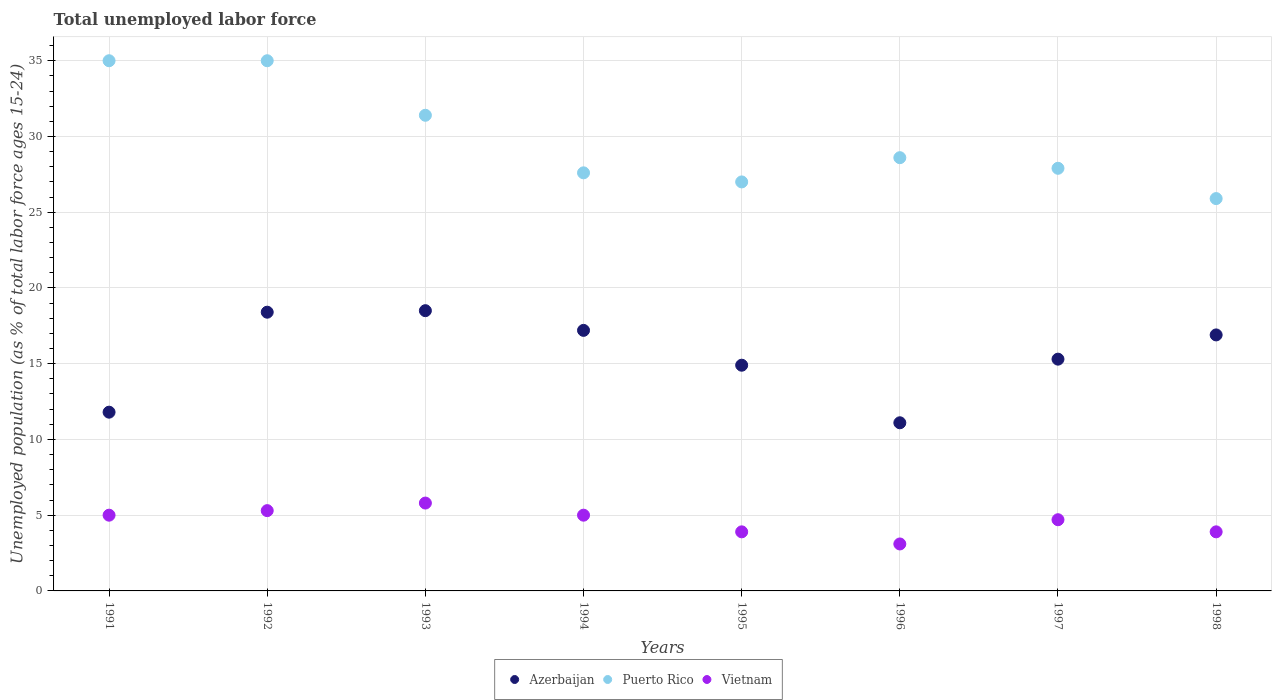How many different coloured dotlines are there?
Offer a very short reply. 3. Is the number of dotlines equal to the number of legend labels?
Provide a succinct answer. Yes. What is the percentage of unemployed population in in Puerto Rico in 1998?
Your response must be concise. 25.9. Across all years, what is the minimum percentage of unemployed population in in Vietnam?
Make the answer very short. 3.1. In which year was the percentage of unemployed population in in Vietnam maximum?
Provide a short and direct response. 1993. What is the total percentage of unemployed population in in Vietnam in the graph?
Give a very brief answer. 36.7. What is the difference between the percentage of unemployed population in in Vietnam in 1995 and that in 1997?
Make the answer very short. -0.8. What is the difference between the percentage of unemployed population in in Vietnam in 1993 and the percentage of unemployed population in in Azerbaijan in 1995?
Give a very brief answer. -9.1. What is the average percentage of unemployed population in in Azerbaijan per year?
Your answer should be very brief. 15.51. In the year 1992, what is the difference between the percentage of unemployed population in in Azerbaijan and percentage of unemployed population in in Puerto Rico?
Make the answer very short. -16.6. In how many years, is the percentage of unemployed population in in Vietnam greater than 6 %?
Ensure brevity in your answer.  0. What is the ratio of the percentage of unemployed population in in Vietnam in 1991 to that in 1997?
Offer a terse response. 1.06. Is the percentage of unemployed population in in Azerbaijan in 1994 less than that in 1997?
Offer a terse response. No. What is the difference between the highest and the second highest percentage of unemployed population in in Azerbaijan?
Your answer should be compact. 0.1. What is the difference between the highest and the lowest percentage of unemployed population in in Vietnam?
Make the answer very short. 2.7. In how many years, is the percentage of unemployed population in in Vietnam greater than the average percentage of unemployed population in in Vietnam taken over all years?
Your answer should be very brief. 5. Does the percentage of unemployed population in in Vietnam monotonically increase over the years?
Provide a succinct answer. No. Is the percentage of unemployed population in in Vietnam strictly greater than the percentage of unemployed population in in Puerto Rico over the years?
Your response must be concise. No. Is the percentage of unemployed population in in Puerto Rico strictly less than the percentage of unemployed population in in Vietnam over the years?
Your answer should be very brief. No. How many years are there in the graph?
Offer a terse response. 8. What is the difference between two consecutive major ticks on the Y-axis?
Your response must be concise. 5. Are the values on the major ticks of Y-axis written in scientific E-notation?
Offer a very short reply. No. Does the graph contain any zero values?
Provide a short and direct response. No. Where does the legend appear in the graph?
Your response must be concise. Bottom center. How many legend labels are there?
Offer a very short reply. 3. What is the title of the graph?
Keep it short and to the point. Total unemployed labor force. Does "Mexico" appear as one of the legend labels in the graph?
Your response must be concise. No. What is the label or title of the X-axis?
Your response must be concise. Years. What is the label or title of the Y-axis?
Your answer should be compact. Unemployed population (as % of total labor force ages 15-24). What is the Unemployed population (as % of total labor force ages 15-24) in Azerbaijan in 1991?
Offer a terse response. 11.8. What is the Unemployed population (as % of total labor force ages 15-24) in Puerto Rico in 1991?
Offer a very short reply. 35. What is the Unemployed population (as % of total labor force ages 15-24) of Vietnam in 1991?
Your answer should be very brief. 5. What is the Unemployed population (as % of total labor force ages 15-24) in Azerbaijan in 1992?
Offer a very short reply. 18.4. What is the Unemployed population (as % of total labor force ages 15-24) of Puerto Rico in 1992?
Your response must be concise. 35. What is the Unemployed population (as % of total labor force ages 15-24) of Vietnam in 1992?
Your answer should be compact. 5.3. What is the Unemployed population (as % of total labor force ages 15-24) of Puerto Rico in 1993?
Make the answer very short. 31.4. What is the Unemployed population (as % of total labor force ages 15-24) of Vietnam in 1993?
Make the answer very short. 5.8. What is the Unemployed population (as % of total labor force ages 15-24) in Azerbaijan in 1994?
Make the answer very short. 17.2. What is the Unemployed population (as % of total labor force ages 15-24) in Puerto Rico in 1994?
Provide a short and direct response. 27.6. What is the Unemployed population (as % of total labor force ages 15-24) of Azerbaijan in 1995?
Your answer should be compact. 14.9. What is the Unemployed population (as % of total labor force ages 15-24) in Puerto Rico in 1995?
Your response must be concise. 27. What is the Unemployed population (as % of total labor force ages 15-24) of Vietnam in 1995?
Your answer should be very brief. 3.9. What is the Unemployed population (as % of total labor force ages 15-24) of Azerbaijan in 1996?
Ensure brevity in your answer.  11.1. What is the Unemployed population (as % of total labor force ages 15-24) of Puerto Rico in 1996?
Your response must be concise. 28.6. What is the Unemployed population (as % of total labor force ages 15-24) of Vietnam in 1996?
Offer a terse response. 3.1. What is the Unemployed population (as % of total labor force ages 15-24) in Azerbaijan in 1997?
Keep it short and to the point. 15.3. What is the Unemployed population (as % of total labor force ages 15-24) of Puerto Rico in 1997?
Your answer should be compact. 27.9. What is the Unemployed population (as % of total labor force ages 15-24) in Vietnam in 1997?
Your response must be concise. 4.7. What is the Unemployed population (as % of total labor force ages 15-24) in Azerbaijan in 1998?
Provide a short and direct response. 16.9. What is the Unemployed population (as % of total labor force ages 15-24) in Puerto Rico in 1998?
Make the answer very short. 25.9. What is the Unemployed population (as % of total labor force ages 15-24) in Vietnam in 1998?
Keep it short and to the point. 3.9. Across all years, what is the maximum Unemployed population (as % of total labor force ages 15-24) in Puerto Rico?
Your answer should be compact. 35. Across all years, what is the maximum Unemployed population (as % of total labor force ages 15-24) of Vietnam?
Provide a succinct answer. 5.8. Across all years, what is the minimum Unemployed population (as % of total labor force ages 15-24) in Azerbaijan?
Your answer should be compact. 11.1. Across all years, what is the minimum Unemployed population (as % of total labor force ages 15-24) in Puerto Rico?
Make the answer very short. 25.9. Across all years, what is the minimum Unemployed population (as % of total labor force ages 15-24) of Vietnam?
Provide a succinct answer. 3.1. What is the total Unemployed population (as % of total labor force ages 15-24) of Azerbaijan in the graph?
Ensure brevity in your answer.  124.1. What is the total Unemployed population (as % of total labor force ages 15-24) in Puerto Rico in the graph?
Your answer should be very brief. 238.4. What is the total Unemployed population (as % of total labor force ages 15-24) in Vietnam in the graph?
Provide a succinct answer. 36.7. What is the difference between the Unemployed population (as % of total labor force ages 15-24) in Puerto Rico in 1991 and that in 1992?
Give a very brief answer. 0. What is the difference between the Unemployed population (as % of total labor force ages 15-24) in Vietnam in 1991 and that in 1993?
Offer a terse response. -0.8. What is the difference between the Unemployed population (as % of total labor force ages 15-24) in Azerbaijan in 1991 and that in 1994?
Give a very brief answer. -5.4. What is the difference between the Unemployed population (as % of total labor force ages 15-24) in Puerto Rico in 1991 and that in 1994?
Ensure brevity in your answer.  7.4. What is the difference between the Unemployed population (as % of total labor force ages 15-24) of Azerbaijan in 1991 and that in 1995?
Offer a very short reply. -3.1. What is the difference between the Unemployed population (as % of total labor force ages 15-24) of Puerto Rico in 1991 and that in 1996?
Your answer should be compact. 6.4. What is the difference between the Unemployed population (as % of total labor force ages 15-24) of Azerbaijan in 1991 and that in 1997?
Provide a short and direct response. -3.5. What is the difference between the Unemployed population (as % of total labor force ages 15-24) of Puerto Rico in 1991 and that in 1997?
Give a very brief answer. 7.1. What is the difference between the Unemployed population (as % of total labor force ages 15-24) of Vietnam in 1991 and that in 1997?
Provide a succinct answer. 0.3. What is the difference between the Unemployed population (as % of total labor force ages 15-24) in Azerbaijan in 1991 and that in 1998?
Provide a succinct answer. -5.1. What is the difference between the Unemployed population (as % of total labor force ages 15-24) of Puerto Rico in 1991 and that in 1998?
Your response must be concise. 9.1. What is the difference between the Unemployed population (as % of total labor force ages 15-24) in Azerbaijan in 1992 and that in 1993?
Keep it short and to the point. -0.1. What is the difference between the Unemployed population (as % of total labor force ages 15-24) in Puerto Rico in 1992 and that in 1993?
Your response must be concise. 3.6. What is the difference between the Unemployed population (as % of total labor force ages 15-24) in Azerbaijan in 1992 and that in 1995?
Give a very brief answer. 3.5. What is the difference between the Unemployed population (as % of total labor force ages 15-24) of Vietnam in 1992 and that in 1995?
Your answer should be very brief. 1.4. What is the difference between the Unemployed population (as % of total labor force ages 15-24) of Puerto Rico in 1992 and that in 1996?
Provide a short and direct response. 6.4. What is the difference between the Unemployed population (as % of total labor force ages 15-24) of Azerbaijan in 1992 and that in 1998?
Offer a very short reply. 1.5. What is the difference between the Unemployed population (as % of total labor force ages 15-24) of Puerto Rico in 1992 and that in 1998?
Give a very brief answer. 9.1. What is the difference between the Unemployed population (as % of total labor force ages 15-24) in Puerto Rico in 1993 and that in 1994?
Your answer should be very brief. 3.8. What is the difference between the Unemployed population (as % of total labor force ages 15-24) of Puerto Rico in 1993 and that in 1995?
Give a very brief answer. 4.4. What is the difference between the Unemployed population (as % of total labor force ages 15-24) of Vietnam in 1993 and that in 1995?
Keep it short and to the point. 1.9. What is the difference between the Unemployed population (as % of total labor force ages 15-24) in Puerto Rico in 1993 and that in 1996?
Keep it short and to the point. 2.8. What is the difference between the Unemployed population (as % of total labor force ages 15-24) in Puerto Rico in 1993 and that in 1997?
Your answer should be compact. 3.5. What is the difference between the Unemployed population (as % of total labor force ages 15-24) in Vietnam in 1993 and that in 1998?
Keep it short and to the point. 1.9. What is the difference between the Unemployed population (as % of total labor force ages 15-24) in Azerbaijan in 1994 and that in 1996?
Give a very brief answer. 6.1. What is the difference between the Unemployed population (as % of total labor force ages 15-24) of Vietnam in 1994 and that in 1996?
Provide a succinct answer. 1.9. What is the difference between the Unemployed population (as % of total labor force ages 15-24) of Azerbaijan in 1994 and that in 1997?
Offer a very short reply. 1.9. What is the difference between the Unemployed population (as % of total labor force ages 15-24) of Puerto Rico in 1994 and that in 1997?
Provide a short and direct response. -0.3. What is the difference between the Unemployed population (as % of total labor force ages 15-24) of Azerbaijan in 1994 and that in 1998?
Make the answer very short. 0.3. What is the difference between the Unemployed population (as % of total labor force ages 15-24) in Puerto Rico in 1994 and that in 1998?
Make the answer very short. 1.7. What is the difference between the Unemployed population (as % of total labor force ages 15-24) in Vietnam in 1994 and that in 1998?
Provide a short and direct response. 1.1. What is the difference between the Unemployed population (as % of total labor force ages 15-24) in Puerto Rico in 1995 and that in 1996?
Offer a terse response. -1.6. What is the difference between the Unemployed population (as % of total labor force ages 15-24) in Azerbaijan in 1995 and that in 1997?
Your answer should be compact. -0.4. What is the difference between the Unemployed population (as % of total labor force ages 15-24) in Puerto Rico in 1995 and that in 1998?
Offer a very short reply. 1.1. What is the difference between the Unemployed population (as % of total labor force ages 15-24) in Puerto Rico in 1996 and that in 1997?
Your answer should be very brief. 0.7. What is the difference between the Unemployed population (as % of total labor force ages 15-24) in Vietnam in 1996 and that in 1997?
Your response must be concise. -1.6. What is the difference between the Unemployed population (as % of total labor force ages 15-24) of Azerbaijan in 1996 and that in 1998?
Keep it short and to the point. -5.8. What is the difference between the Unemployed population (as % of total labor force ages 15-24) of Vietnam in 1997 and that in 1998?
Offer a terse response. 0.8. What is the difference between the Unemployed population (as % of total labor force ages 15-24) of Azerbaijan in 1991 and the Unemployed population (as % of total labor force ages 15-24) of Puerto Rico in 1992?
Ensure brevity in your answer.  -23.2. What is the difference between the Unemployed population (as % of total labor force ages 15-24) of Puerto Rico in 1991 and the Unemployed population (as % of total labor force ages 15-24) of Vietnam in 1992?
Offer a very short reply. 29.7. What is the difference between the Unemployed population (as % of total labor force ages 15-24) of Azerbaijan in 1991 and the Unemployed population (as % of total labor force ages 15-24) of Puerto Rico in 1993?
Make the answer very short. -19.6. What is the difference between the Unemployed population (as % of total labor force ages 15-24) in Azerbaijan in 1991 and the Unemployed population (as % of total labor force ages 15-24) in Vietnam in 1993?
Offer a very short reply. 6. What is the difference between the Unemployed population (as % of total labor force ages 15-24) of Puerto Rico in 1991 and the Unemployed population (as % of total labor force ages 15-24) of Vietnam in 1993?
Offer a terse response. 29.2. What is the difference between the Unemployed population (as % of total labor force ages 15-24) in Azerbaijan in 1991 and the Unemployed population (as % of total labor force ages 15-24) in Puerto Rico in 1994?
Give a very brief answer. -15.8. What is the difference between the Unemployed population (as % of total labor force ages 15-24) of Puerto Rico in 1991 and the Unemployed population (as % of total labor force ages 15-24) of Vietnam in 1994?
Offer a terse response. 30. What is the difference between the Unemployed population (as % of total labor force ages 15-24) in Azerbaijan in 1991 and the Unemployed population (as % of total labor force ages 15-24) in Puerto Rico in 1995?
Make the answer very short. -15.2. What is the difference between the Unemployed population (as % of total labor force ages 15-24) of Puerto Rico in 1991 and the Unemployed population (as % of total labor force ages 15-24) of Vietnam in 1995?
Ensure brevity in your answer.  31.1. What is the difference between the Unemployed population (as % of total labor force ages 15-24) of Azerbaijan in 1991 and the Unemployed population (as % of total labor force ages 15-24) of Puerto Rico in 1996?
Your answer should be very brief. -16.8. What is the difference between the Unemployed population (as % of total labor force ages 15-24) of Azerbaijan in 1991 and the Unemployed population (as % of total labor force ages 15-24) of Vietnam in 1996?
Offer a terse response. 8.7. What is the difference between the Unemployed population (as % of total labor force ages 15-24) in Puerto Rico in 1991 and the Unemployed population (as % of total labor force ages 15-24) in Vietnam in 1996?
Offer a very short reply. 31.9. What is the difference between the Unemployed population (as % of total labor force ages 15-24) of Azerbaijan in 1991 and the Unemployed population (as % of total labor force ages 15-24) of Puerto Rico in 1997?
Offer a terse response. -16.1. What is the difference between the Unemployed population (as % of total labor force ages 15-24) in Puerto Rico in 1991 and the Unemployed population (as % of total labor force ages 15-24) in Vietnam in 1997?
Provide a short and direct response. 30.3. What is the difference between the Unemployed population (as % of total labor force ages 15-24) in Azerbaijan in 1991 and the Unemployed population (as % of total labor force ages 15-24) in Puerto Rico in 1998?
Your answer should be very brief. -14.1. What is the difference between the Unemployed population (as % of total labor force ages 15-24) of Azerbaijan in 1991 and the Unemployed population (as % of total labor force ages 15-24) of Vietnam in 1998?
Your answer should be very brief. 7.9. What is the difference between the Unemployed population (as % of total labor force ages 15-24) of Puerto Rico in 1991 and the Unemployed population (as % of total labor force ages 15-24) of Vietnam in 1998?
Ensure brevity in your answer.  31.1. What is the difference between the Unemployed population (as % of total labor force ages 15-24) in Azerbaijan in 1992 and the Unemployed population (as % of total labor force ages 15-24) in Vietnam in 1993?
Ensure brevity in your answer.  12.6. What is the difference between the Unemployed population (as % of total labor force ages 15-24) in Puerto Rico in 1992 and the Unemployed population (as % of total labor force ages 15-24) in Vietnam in 1993?
Offer a terse response. 29.2. What is the difference between the Unemployed population (as % of total labor force ages 15-24) of Azerbaijan in 1992 and the Unemployed population (as % of total labor force ages 15-24) of Puerto Rico in 1995?
Provide a succinct answer. -8.6. What is the difference between the Unemployed population (as % of total labor force ages 15-24) in Puerto Rico in 1992 and the Unemployed population (as % of total labor force ages 15-24) in Vietnam in 1995?
Give a very brief answer. 31.1. What is the difference between the Unemployed population (as % of total labor force ages 15-24) in Azerbaijan in 1992 and the Unemployed population (as % of total labor force ages 15-24) in Puerto Rico in 1996?
Give a very brief answer. -10.2. What is the difference between the Unemployed population (as % of total labor force ages 15-24) in Puerto Rico in 1992 and the Unemployed population (as % of total labor force ages 15-24) in Vietnam in 1996?
Your answer should be compact. 31.9. What is the difference between the Unemployed population (as % of total labor force ages 15-24) of Azerbaijan in 1992 and the Unemployed population (as % of total labor force ages 15-24) of Puerto Rico in 1997?
Your response must be concise. -9.5. What is the difference between the Unemployed population (as % of total labor force ages 15-24) of Azerbaijan in 1992 and the Unemployed population (as % of total labor force ages 15-24) of Vietnam in 1997?
Make the answer very short. 13.7. What is the difference between the Unemployed population (as % of total labor force ages 15-24) of Puerto Rico in 1992 and the Unemployed population (as % of total labor force ages 15-24) of Vietnam in 1997?
Your answer should be compact. 30.3. What is the difference between the Unemployed population (as % of total labor force ages 15-24) of Azerbaijan in 1992 and the Unemployed population (as % of total labor force ages 15-24) of Vietnam in 1998?
Offer a terse response. 14.5. What is the difference between the Unemployed population (as % of total labor force ages 15-24) in Puerto Rico in 1992 and the Unemployed population (as % of total labor force ages 15-24) in Vietnam in 1998?
Your answer should be compact. 31.1. What is the difference between the Unemployed population (as % of total labor force ages 15-24) of Puerto Rico in 1993 and the Unemployed population (as % of total labor force ages 15-24) of Vietnam in 1994?
Your response must be concise. 26.4. What is the difference between the Unemployed population (as % of total labor force ages 15-24) in Azerbaijan in 1993 and the Unemployed population (as % of total labor force ages 15-24) in Puerto Rico in 1995?
Ensure brevity in your answer.  -8.5. What is the difference between the Unemployed population (as % of total labor force ages 15-24) in Azerbaijan in 1993 and the Unemployed population (as % of total labor force ages 15-24) in Puerto Rico in 1996?
Provide a short and direct response. -10.1. What is the difference between the Unemployed population (as % of total labor force ages 15-24) in Azerbaijan in 1993 and the Unemployed population (as % of total labor force ages 15-24) in Vietnam in 1996?
Your answer should be compact. 15.4. What is the difference between the Unemployed population (as % of total labor force ages 15-24) of Puerto Rico in 1993 and the Unemployed population (as % of total labor force ages 15-24) of Vietnam in 1996?
Your response must be concise. 28.3. What is the difference between the Unemployed population (as % of total labor force ages 15-24) in Azerbaijan in 1993 and the Unemployed population (as % of total labor force ages 15-24) in Vietnam in 1997?
Make the answer very short. 13.8. What is the difference between the Unemployed population (as % of total labor force ages 15-24) of Puerto Rico in 1993 and the Unemployed population (as % of total labor force ages 15-24) of Vietnam in 1997?
Your response must be concise. 26.7. What is the difference between the Unemployed population (as % of total labor force ages 15-24) of Puerto Rico in 1993 and the Unemployed population (as % of total labor force ages 15-24) of Vietnam in 1998?
Your answer should be very brief. 27.5. What is the difference between the Unemployed population (as % of total labor force ages 15-24) of Puerto Rico in 1994 and the Unemployed population (as % of total labor force ages 15-24) of Vietnam in 1995?
Provide a short and direct response. 23.7. What is the difference between the Unemployed population (as % of total labor force ages 15-24) in Azerbaijan in 1994 and the Unemployed population (as % of total labor force ages 15-24) in Puerto Rico in 1997?
Ensure brevity in your answer.  -10.7. What is the difference between the Unemployed population (as % of total labor force ages 15-24) in Puerto Rico in 1994 and the Unemployed population (as % of total labor force ages 15-24) in Vietnam in 1997?
Provide a succinct answer. 22.9. What is the difference between the Unemployed population (as % of total labor force ages 15-24) in Azerbaijan in 1994 and the Unemployed population (as % of total labor force ages 15-24) in Vietnam in 1998?
Provide a succinct answer. 13.3. What is the difference between the Unemployed population (as % of total labor force ages 15-24) in Puerto Rico in 1994 and the Unemployed population (as % of total labor force ages 15-24) in Vietnam in 1998?
Offer a terse response. 23.7. What is the difference between the Unemployed population (as % of total labor force ages 15-24) in Azerbaijan in 1995 and the Unemployed population (as % of total labor force ages 15-24) in Puerto Rico in 1996?
Offer a very short reply. -13.7. What is the difference between the Unemployed population (as % of total labor force ages 15-24) in Azerbaijan in 1995 and the Unemployed population (as % of total labor force ages 15-24) in Vietnam in 1996?
Your response must be concise. 11.8. What is the difference between the Unemployed population (as % of total labor force ages 15-24) of Puerto Rico in 1995 and the Unemployed population (as % of total labor force ages 15-24) of Vietnam in 1996?
Your answer should be very brief. 23.9. What is the difference between the Unemployed population (as % of total labor force ages 15-24) in Azerbaijan in 1995 and the Unemployed population (as % of total labor force ages 15-24) in Puerto Rico in 1997?
Ensure brevity in your answer.  -13. What is the difference between the Unemployed population (as % of total labor force ages 15-24) of Azerbaijan in 1995 and the Unemployed population (as % of total labor force ages 15-24) of Vietnam in 1997?
Your answer should be very brief. 10.2. What is the difference between the Unemployed population (as % of total labor force ages 15-24) in Puerto Rico in 1995 and the Unemployed population (as % of total labor force ages 15-24) in Vietnam in 1997?
Your answer should be compact. 22.3. What is the difference between the Unemployed population (as % of total labor force ages 15-24) of Azerbaijan in 1995 and the Unemployed population (as % of total labor force ages 15-24) of Vietnam in 1998?
Keep it short and to the point. 11. What is the difference between the Unemployed population (as % of total labor force ages 15-24) in Puerto Rico in 1995 and the Unemployed population (as % of total labor force ages 15-24) in Vietnam in 1998?
Offer a terse response. 23.1. What is the difference between the Unemployed population (as % of total labor force ages 15-24) in Azerbaijan in 1996 and the Unemployed population (as % of total labor force ages 15-24) in Puerto Rico in 1997?
Offer a terse response. -16.8. What is the difference between the Unemployed population (as % of total labor force ages 15-24) of Puerto Rico in 1996 and the Unemployed population (as % of total labor force ages 15-24) of Vietnam in 1997?
Offer a very short reply. 23.9. What is the difference between the Unemployed population (as % of total labor force ages 15-24) in Azerbaijan in 1996 and the Unemployed population (as % of total labor force ages 15-24) in Puerto Rico in 1998?
Keep it short and to the point. -14.8. What is the difference between the Unemployed population (as % of total labor force ages 15-24) of Puerto Rico in 1996 and the Unemployed population (as % of total labor force ages 15-24) of Vietnam in 1998?
Your response must be concise. 24.7. What is the difference between the Unemployed population (as % of total labor force ages 15-24) in Puerto Rico in 1997 and the Unemployed population (as % of total labor force ages 15-24) in Vietnam in 1998?
Give a very brief answer. 24. What is the average Unemployed population (as % of total labor force ages 15-24) of Azerbaijan per year?
Give a very brief answer. 15.51. What is the average Unemployed population (as % of total labor force ages 15-24) of Puerto Rico per year?
Provide a short and direct response. 29.8. What is the average Unemployed population (as % of total labor force ages 15-24) in Vietnam per year?
Your answer should be very brief. 4.59. In the year 1991, what is the difference between the Unemployed population (as % of total labor force ages 15-24) in Azerbaijan and Unemployed population (as % of total labor force ages 15-24) in Puerto Rico?
Your answer should be compact. -23.2. In the year 1992, what is the difference between the Unemployed population (as % of total labor force ages 15-24) of Azerbaijan and Unemployed population (as % of total labor force ages 15-24) of Puerto Rico?
Provide a short and direct response. -16.6. In the year 1992, what is the difference between the Unemployed population (as % of total labor force ages 15-24) in Azerbaijan and Unemployed population (as % of total labor force ages 15-24) in Vietnam?
Provide a succinct answer. 13.1. In the year 1992, what is the difference between the Unemployed population (as % of total labor force ages 15-24) in Puerto Rico and Unemployed population (as % of total labor force ages 15-24) in Vietnam?
Provide a short and direct response. 29.7. In the year 1993, what is the difference between the Unemployed population (as % of total labor force ages 15-24) of Azerbaijan and Unemployed population (as % of total labor force ages 15-24) of Puerto Rico?
Offer a terse response. -12.9. In the year 1993, what is the difference between the Unemployed population (as % of total labor force ages 15-24) in Puerto Rico and Unemployed population (as % of total labor force ages 15-24) in Vietnam?
Your response must be concise. 25.6. In the year 1994, what is the difference between the Unemployed population (as % of total labor force ages 15-24) of Azerbaijan and Unemployed population (as % of total labor force ages 15-24) of Vietnam?
Provide a short and direct response. 12.2. In the year 1994, what is the difference between the Unemployed population (as % of total labor force ages 15-24) in Puerto Rico and Unemployed population (as % of total labor force ages 15-24) in Vietnam?
Your response must be concise. 22.6. In the year 1995, what is the difference between the Unemployed population (as % of total labor force ages 15-24) in Azerbaijan and Unemployed population (as % of total labor force ages 15-24) in Puerto Rico?
Ensure brevity in your answer.  -12.1. In the year 1995, what is the difference between the Unemployed population (as % of total labor force ages 15-24) in Azerbaijan and Unemployed population (as % of total labor force ages 15-24) in Vietnam?
Provide a short and direct response. 11. In the year 1995, what is the difference between the Unemployed population (as % of total labor force ages 15-24) in Puerto Rico and Unemployed population (as % of total labor force ages 15-24) in Vietnam?
Your answer should be very brief. 23.1. In the year 1996, what is the difference between the Unemployed population (as % of total labor force ages 15-24) in Azerbaijan and Unemployed population (as % of total labor force ages 15-24) in Puerto Rico?
Ensure brevity in your answer.  -17.5. In the year 1996, what is the difference between the Unemployed population (as % of total labor force ages 15-24) of Azerbaijan and Unemployed population (as % of total labor force ages 15-24) of Vietnam?
Keep it short and to the point. 8. In the year 1996, what is the difference between the Unemployed population (as % of total labor force ages 15-24) of Puerto Rico and Unemployed population (as % of total labor force ages 15-24) of Vietnam?
Make the answer very short. 25.5. In the year 1997, what is the difference between the Unemployed population (as % of total labor force ages 15-24) in Azerbaijan and Unemployed population (as % of total labor force ages 15-24) in Puerto Rico?
Give a very brief answer. -12.6. In the year 1997, what is the difference between the Unemployed population (as % of total labor force ages 15-24) in Azerbaijan and Unemployed population (as % of total labor force ages 15-24) in Vietnam?
Provide a short and direct response. 10.6. In the year 1997, what is the difference between the Unemployed population (as % of total labor force ages 15-24) of Puerto Rico and Unemployed population (as % of total labor force ages 15-24) of Vietnam?
Give a very brief answer. 23.2. What is the ratio of the Unemployed population (as % of total labor force ages 15-24) in Azerbaijan in 1991 to that in 1992?
Provide a succinct answer. 0.64. What is the ratio of the Unemployed population (as % of total labor force ages 15-24) in Vietnam in 1991 to that in 1992?
Your answer should be very brief. 0.94. What is the ratio of the Unemployed population (as % of total labor force ages 15-24) of Azerbaijan in 1991 to that in 1993?
Your answer should be compact. 0.64. What is the ratio of the Unemployed population (as % of total labor force ages 15-24) in Puerto Rico in 1991 to that in 1993?
Give a very brief answer. 1.11. What is the ratio of the Unemployed population (as % of total labor force ages 15-24) in Vietnam in 1991 to that in 1993?
Make the answer very short. 0.86. What is the ratio of the Unemployed population (as % of total labor force ages 15-24) of Azerbaijan in 1991 to that in 1994?
Offer a very short reply. 0.69. What is the ratio of the Unemployed population (as % of total labor force ages 15-24) of Puerto Rico in 1991 to that in 1994?
Your answer should be very brief. 1.27. What is the ratio of the Unemployed population (as % of total labor force ages 15-24) of Azerbaijan in 1991 to that in 1995?
Provide a short and direct response. 0.79. What is the ratio of the Unemployed population (as % of total labor force ages 15-24) in Puerto Rico in 1991 to that in 1995?
Keep it short and to the point. 1.3. What is the ratio of the Unemployed population (as % of total labor force ages 15-24) of Vietnam in 1991 to that in 1995?
Give a very brief answer. 1.28. What is the ratio of the Unemployed population (as % of total labor force ages 15-24) in Azerbaijan in 1991 to that in 1996?
Your answer should be very brief. 1.06. What is the ratio of the Unemployed population (as % of total labor force ages 15-24) of Puerto Rico in 1991 to that in 1996?
Your response must be concise. 1.22. What is the ratio of the Unemployed population (as % of total labor force ages 15-24) of Vietnam in 1991 to that in 1996?
Your response must be concise. 1.61. What is the ratio of the Unemployed population (as % of total labor force ages 15-24) in Azerbaijan in 1991 to that in 1997?
Ensure brevity in your answer.  0.77. What is the ratio of the Unemployed population (as % of total labor force ages 15-24) in Puerto Rico in 1991 to that in 1997?
Offer a very short reply. 1.25. What is the ratio of the Unemployed population (as % of total labor force ages 15-24) in Vietnam in 1991 to that in 1997?
Offer a very short reply. 1.06. What is the ratio of the Unemployed population (as % of total labor force ages 15-24) of Azerbaijan in 1991 to that in 1998?
Make the answer very short. 0.7. What is the ratio of the Unemployed population (as % of total labor force ages 15-24) of Puerto Rico in 1991 to that in 1998?
Provide a short and direct response. 1.35. What is the ratio of the Unemployed population (as % of total labor force ages 15-24) of Vietnam in 1991 to that in 1998?
Make the answer very short. 1.28. What is the ratio of the Unemployed population (as % of total labor force ages 15-24) of Puerto Rico in 1992 to that in 1993?
Make the answer very short. 1.11. What is the ratio of the Unemployed population (as % of total labor force ages 15-24) in Vietnam in 1992 to that in 1993?
Offer a very short reply. 0.91. What is the ratio of the Unemployed population (as % of total labor force ages 15-24) of Azerbaijan in 1992 to that in 1994?
Keep it short and to the point. 1.07. What is the ratio of the Unemployed population (as % of total labor force ages 15-24) of Puerto Rico in 1992 to that in 1994?
Provide a short and direct response. 1.27. What is the ratio of the Unemployed population (as % of total labor force ages 15-24) of Vietnam in 1992 to that in 1994?
Offer a terse response. 1.06. What is the ratio of the Unemployed population (as % of total labor force ages 15-24) in Azerbaijan in 1992 to that in 1995?
Offer a terse response. 1.23. What is the ratio of the Unemployed population (as % of total labor force ages 15-24) in Puerto Rico in 1992 to that in 1995?
Ensure brevity in your answer.  1.3. What is the ratio of the Unemployed population (as % of total labor force ages 15-24) of Vietnam in 1992 to that in 1995?
Your response must be concise. 1.36. What is the ratio of the Unemployed population (as % of total labor force ages 15-24) of Azerbaijan in 1992 to that in 1996?
Ensure brevity in your answer.  1.66. What is the ratio of the Unemployed population (as % of total labor force ages 15-24) in Puerto Rico in 1992 to that in 1996?
Your response must be concise. 1.22. What is the ratio of the Unemployed population (as % of total labor force ages 15-24) of Vietnam in 1992 to that in 1996?
Provide a succinct answer. 1.71. What is the ratio of the Unemployed population (as % of total labor force ages 15-24) in Azerbaijan in 1992 to that in 1997?
Your answer should be very brief. 1.2. What is the ratio of the Unemployed population (as % of total labor force ages 15-24) of Puerto Rico in 1992 to that in 1997?
Your answer should be compact. 1.25. What is the ratio of the Unemployed population (as % of total labor force ages 15-24) in Vietnam in 1992 to that in 1997?
Ensure brevity in your answer.  1.13. What is the ratio of the Unemployed population (as % of total labor force ages 15-24) of Azerbaijan in 1992 to that in 1998?
Ensure brevity in your answer.  1.09. What is the ratio of the Unemployed population (as % of total labor force ages 15-24) in Puerto Rico in 1992 to that in 1998?
Your answer should be very brief. 1.35. What is the ratio of the Unemployed population (as % of total labor force ages 15-24) of Vietnam in 1992 to that in 1998?
Your answer should be compact. 1.36. What is the ratio of the Unemployed population (as % of total labor force ages 15-24) in Azerbaijan in 1993 to that in 1994?
Make the answer very short. 1.08. What is the ratio of the Unemployed population (as % of total labor force ages 15-24) in Puerto Rico in 1993 to that in 1994?
Give a very brief answer. 1.14. What is the ratio of the Unemployed population (as % of total labor force ages 15-24) of Vietnam in 1993 to that in 1994?
Offer a terse response. 1.16. What is the ratio of the Unemployed population (as % of total labor force ages 15-24) of Azerbaijan in 1993 to that in 1995?
Provide a short and direct response. 1.24. What is the ratio of the Unemployed population (as % of total labor force ages 15-24) of Puerto Rico in 1993 to that in 1995?
Offer a terse response. 1.16. What is the ratio of the Unemployed population (as % of total labor force ages 15-24) in Vietnam in 1993 to that in 1995?
Offer a terse response. 1.49. What is the ratio of the Unemployed population (as % of total labor force ages 15-24) of Puerto Rico in 1993 to that in 1996?
Ensure brevity in your answer.  1.1. What is the ratio of the Unemployed population (as % of total labor force ages 15-24) in Vietnam in 1993 to that in 1996?
Make the answer very short. 1.87. What is the ratio of the Unemployed population (as % of total labor force ages 15-24) in Azerbaijan in 1993 to that in 1997?
Your answer should be very brief. 1.21. What is the ratio of the Unemployed population (as % of total labor force ages 15-24) of Puerto Rico in 1993 to that in 1997?
Offer a terse response. 1.13. What is the ratio of the Unemployed population (as % of total labor force ages 15-24) in Vietnam in 1993 to that in 1997?
Keep it short and to the point. 1.23. What is the ratio of the Unemployed population (as % of total labor force ages 15-24) of Azerbaijan in 1993 to that in 1998?
Keep it short and to the point. 1.09. What is the ratio of the Unemployed population (as % of total labor force ages 15-24) in Puerto Rico in 1993 to that in 1998?
Your answer should be very brief. 1.21. What is the ratio of the Unemployed population (as % of total labor force ages 15-24) in Vietnam in 1993 to that in 1998?
Provide a short and direct response. 1.49. What is the ratio of the Unemployed population (as % of total labor force ages 15-24) in Azerbaijan in 1994 to that in 1995?
Offer a terse response. 1.15. What is the ratio of the Unemployed population (as % of total labor force ages 15-24) in Puerto Rico in 1994 to that in 1995?
Offer a very short reply. 1.02. What is the ratio of the Unemployed population (as % of total labor force ages 15-24) in Vietnam in 1994 to that in 1995?
Keep it short and to the point. 1.28. What is the ratio of the Unemployed population (as % of total labor force ages 15-24) of Azerbaijan in 1994 to that in 1996?
Keep it short and to the point. 1.55. What is the ratio of the Unemployed population (as % of total labor force ages 15-24) in Vietnam in 1994 to that in 1996?
Your answer should be very brief. 1.61. What is the ratio of the Unemployed population (as % of total labor force ages 15-24) in Azerbaijan in 1994 to that in 1997?
Ensure brevity in your answer.  1.12. What is the ratio of the Unemployed population (as % of total labor force ages 15-24) in Vietnam in 1994 to that in 1997?
Offer a very short reply. 1.06. What is the ratio of the Unemployed population (as % of total labor force ages 15-24) in Azerbaijan in 1994 to that in 1998?
Make the answer very short. 1.02. What is the ratio of the Unemployed population (as % of total labor force ages 15-24) in Puerto Rico in 1994 to that in 1998?
Your answer should be compact. 1.07. What is the ratio of the Unemployed population (as % of total labor force ages 15-24) of Vietnam in 1994 to that in 1998?
Your answer should be compact. 1.28. What is the ratio of the Unemployed population (as % of total labor force ages 15-24) in Azerbaijan in 1995 to that in 1996?
Give a very brief answer. 1.34. What is the ratio of the Unemployed population (as % of total labor force ages 15-24) of Puerto Rico in 1995 to that in 1996?
Your response must be concise. 0.94. What is the ratio of the Unemployed population (as % of total labor force ages 15-24) of Vietnam in 1995 to that in 1996?
Your answer should be compact. 1.26. What is the ratio of the Unemployed population (as % of total labor force ages 15-24) in Azerbaijan in 1995 to that in 1997?
Give a very brief answer. 0.97. What is the ratio of the Unemployed population (as % of total labor force ages 15-24) in Vietnam in 1995 to that in 1997?
Give a very brief answer. 0.83. What is the ratio of the Unemployed population (as % of total labor force ages 15-24) of Azerbaijan in 1995 to that in 1998?
Provide a short and direct response. 0.88. What is the ratio of the Unemployed population (as % of total labor force ages 15-24) in Puerto Rico in 1995 to that in 1998?
Provide a short and direct response. 1.04. What is the ratio of the Unemployed population (as % of total labor force ages 15-24) of Azerbaijan in 1996 to that in 1997?
Your response must be concise. 0.73. What is the ratio of the Unemployed population (as % of total labor force ages 15-24) in Puerto Rico in 1996 to that in 1997?
Provide a succinct answer. 1.03. What is the ratio of the Unemployed population (as % of total labor force ages 15-24) in Vietnam in 1996 to that in 1997?
Your response must be concise. 0.66. What is the ratio of the Unemployed population (as % of total labor force ages 15-24) in Azerbaijan in 1996 to that in 1998?
Give a very brief answer. 0.66. What is the ratio of the Unemployed population (as % of total labor force ages 15-24) of Puerto Rico in 1996 to that in 1998?
Ensure brevity in your answer.  1.1. What is the ratio of the Unemployed population (as % of total labor force ages 15-24) in Vietnam in 1996 to that in 1998?
Make the answer very short. 0.79. What is the ratio of the Unemployed population (as % of total labor force ages 15-24) of Azerbaijan in 1997 to that in 1998?
Offer a terse response. 0.91. What is the ratio of the Unemployed population (as % of total labor force ages 15-24) in Puerto Rico in 1997 to that in 1998?
Offer a terse response. 1.08. What is the ratio of the Unemployed population (as % of total labor force ages 15-24) in Vietnam in 1997 to that in 1998?
Your response must be concise. 1.21. What is the difference between the highest and the second highest Unemployed population (as % of total labor force ages 15-24) in Puerto Rico?
Your answer should be very brief. 0. What is the difference between the highest and the lowest Unemployed population (as % of total labor force ages 15-24) in Azerbaijan?
Provide a succinct answer. 7.4. 